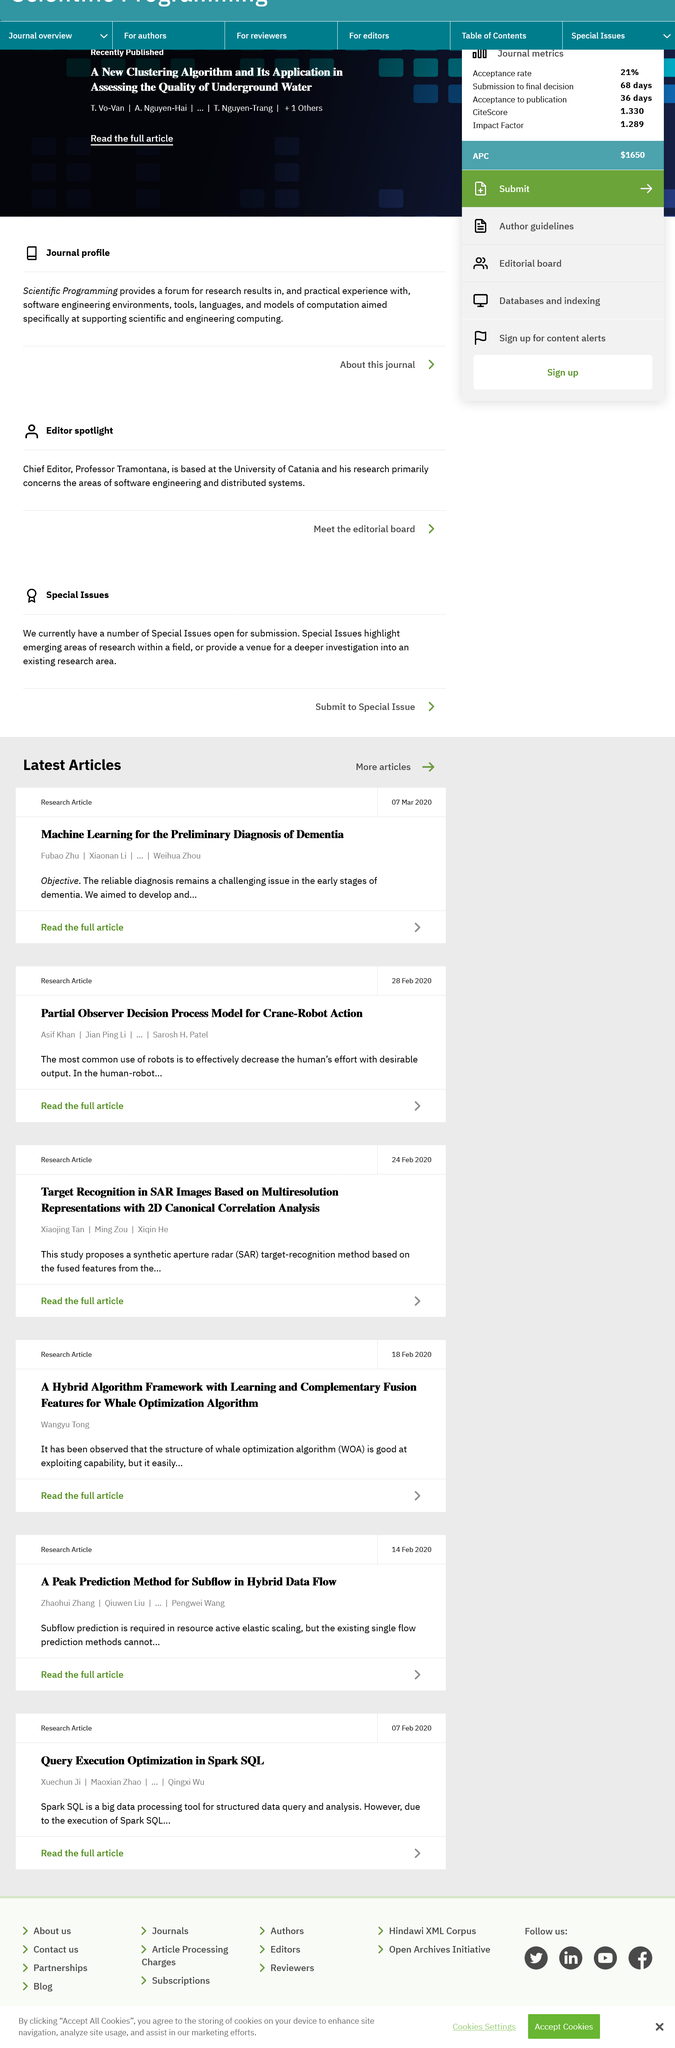Give some essential details in this illustration. Whale Optimization Algorithm, commonly referred to as WOA, is the full name of a popular optimization algorithm used in various fields, including machine learning and artificial intelligence. On 18 Feb 2020, Wangyu Tong wrote an article about the Whale Optimization Algorithm, and it is a fact. Xiaojing Tan is not the author of the article "A Hybrid Algorithm Framework with Learning and Complementary Fusion Features for Whale Optimization Algorithm". 